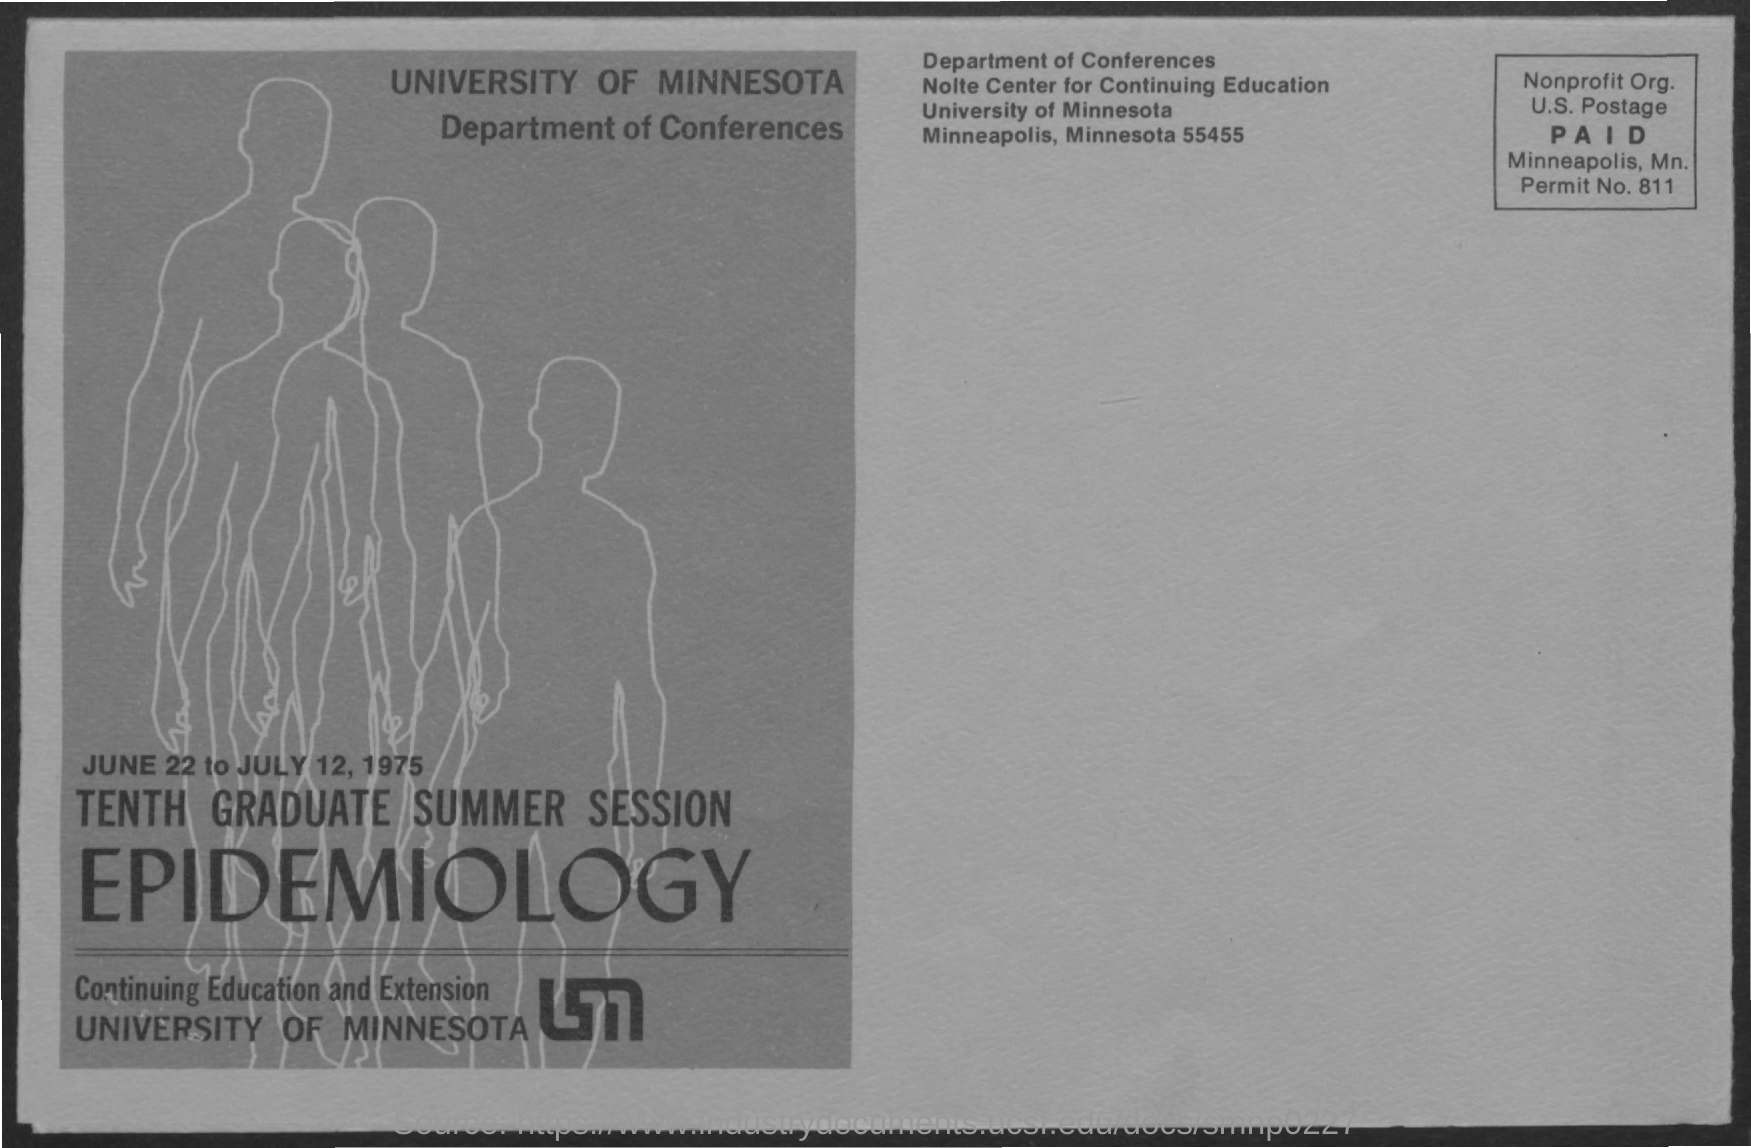List a handful of essential elements in this visual. The University of Minnesota is conducting a Tenth Graduate Summer Session in Epidemiology. What is the permit number mentioned in this document? 811... 